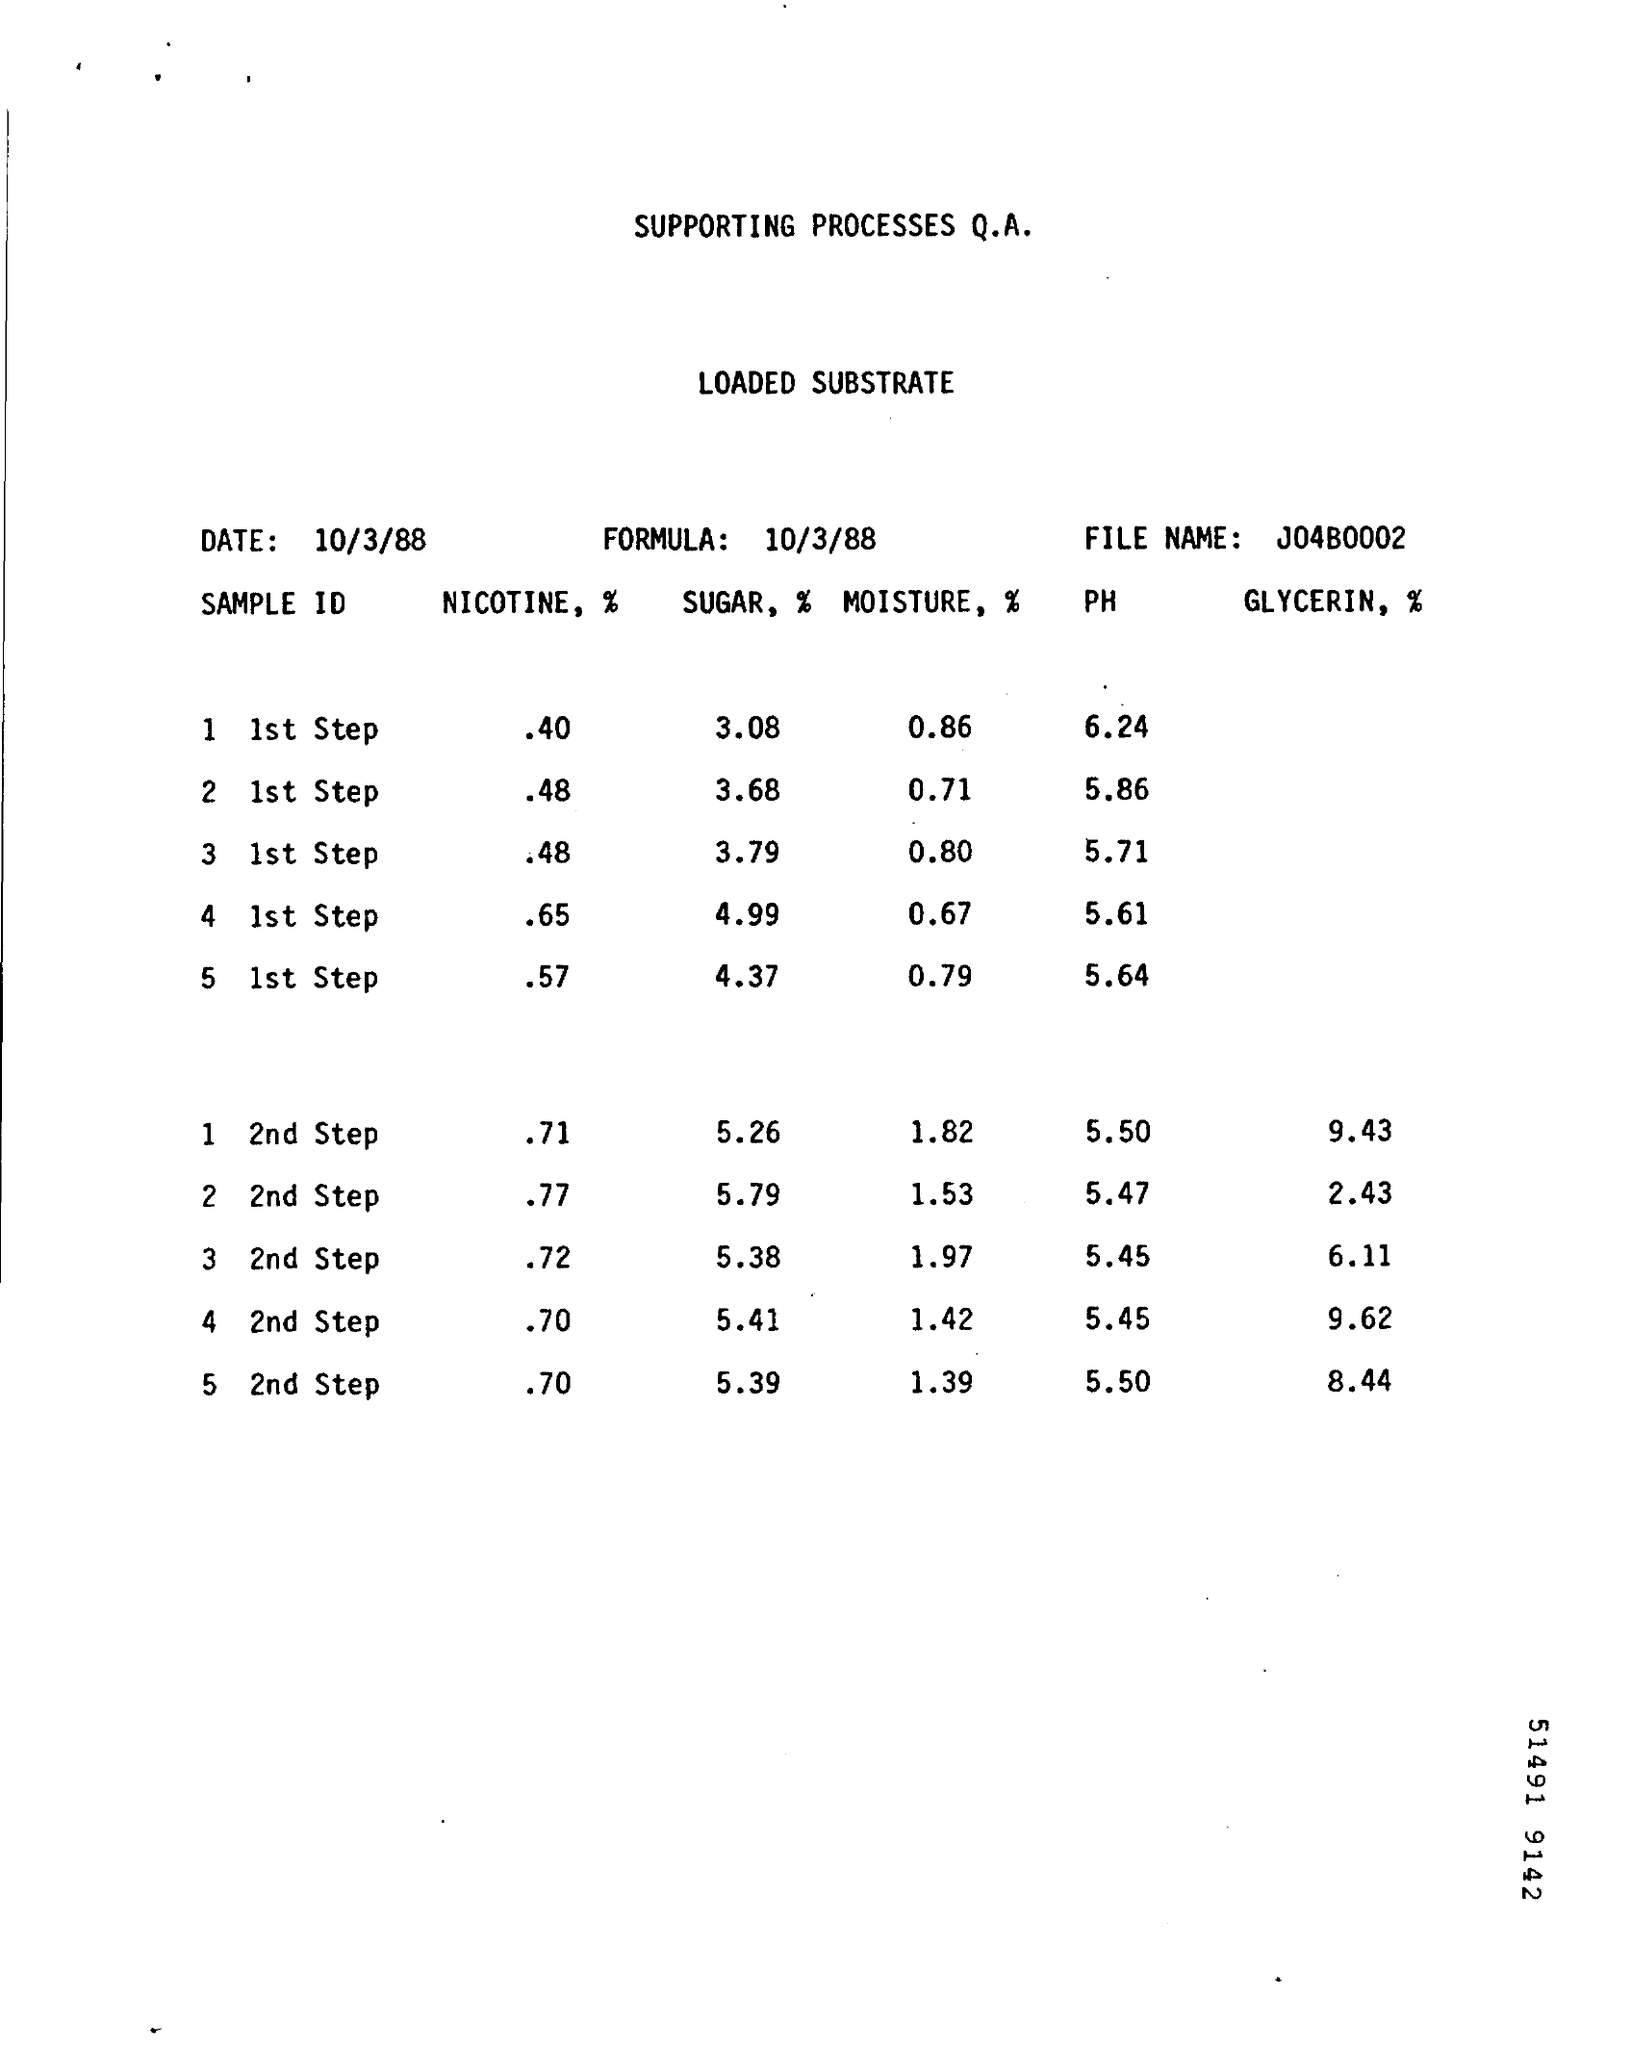What is the File Name ?
Offer a very short reply. J04B0002. What is the date mentioned in the top left ?
Keep it short and to the point. 10/3/88. What is the Formula Date ?
Keep it short and to the point. 10/3/88. 